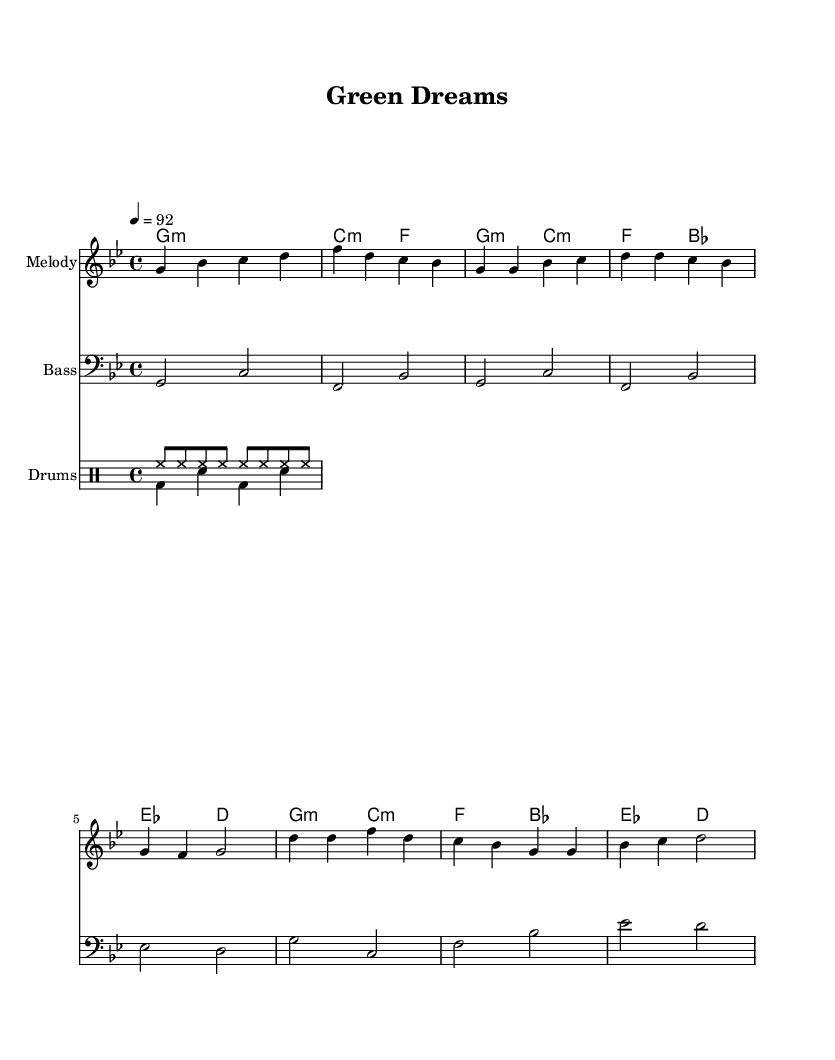What is the key signature of this music? The key signature is G minor, which has two flats: B flat and E flat. This can be identified by examining the key signature at the beginning of the score.
Answer: G minor What is the time signature of the piece? The time signature is 4/4, indicated at the beginning of the score. This means there are four beats in each measure and the quarter note gets one beat.
Answer: 4/4 What is the tempo marking for this music? The tempo marking is quarter note equals 92, which means the piece should be played at 92 beats per minute. This is noted in the score as "4 = 92."
Answer: 92 How many measures are in the Chorus section? The Chorus section consists of 4 measures, which can be seen clearly as it spans from the D note through to the end of that section in the score.
Answer: 4 What is the main rhythmic pattern used in the drum section? The primary rhythmic pattern used in the drum section includes a hi-hat played in eighth notes and a kick-snare pattern that alternates. This can be observed by examining the drum staff notation.
Answer: Alternating kick-snare In which section do we see the introduction of a bass clef? The bass clef is introduced immediately in the score for the bass staff, which is utilized throughout the piece, starting from the intro and continuing into the verse and chorus.
Answer: Bass staff What kind of musical form does the piece follow based on the provided sections? The piece follows a verse-chorus structure, which is common in Hip Hop anthems. This can be determined by identifying the distinct sections labeled as "Verse" and "Chorus" in the score.
Answer: Verse-chorus 